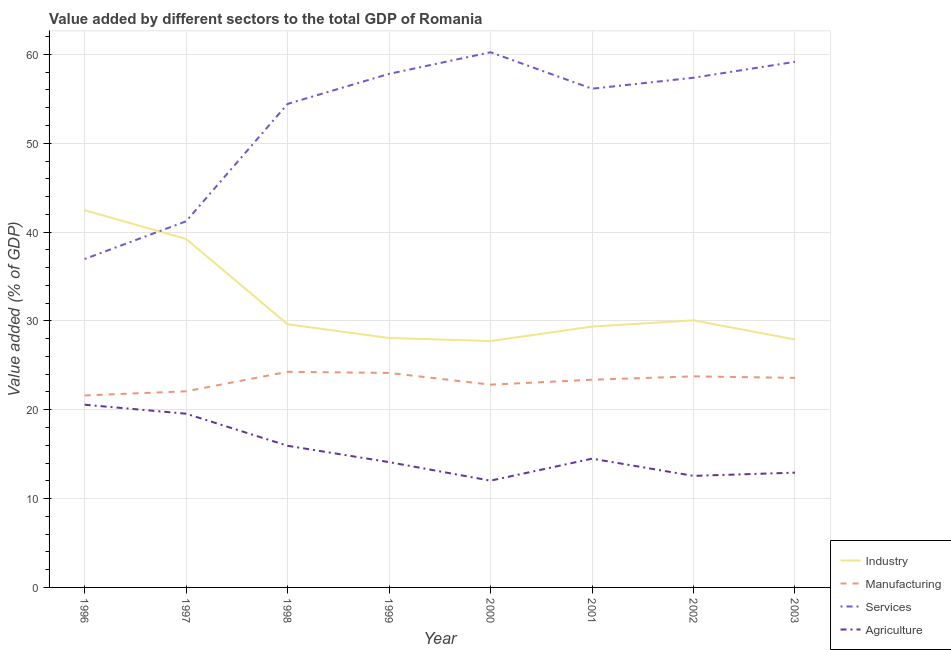Does the line corresponding to value added by services sector intersect with the line corresponding to value added by industrial sector?
Make the answer very short. Yes. Is the number of lines equal to the number of legend labels?
Keep it short and to the point. Yes. What is the value added by services sector in 2003?
Your response must be concise. 59.17. Across all years, what is the maximum value added by industrial sector?
Your response must be concise. 42.46. Across all years, what is the minimum value added by industrial sector?
Your response must be concise. 27.73. In which year was the value added by services sector minimum?
Your answer should be very brief. 1996. What is the total value added by industrial sector in the graph?
Your answer should be compact. 254.47. What is the difference between the value added by agricultural sector in 1999 and that in 2002?
Give a very brief answer. 1.55. What is the difference between the value added by industrial sector in 2000 and the value added by agricultural sector in 2001?
Provide a short and direct response. 13.24. What is the average value added by agricultural sector per year?
Your response must be concise. 15.27. In the year 2003, what is the difference between the value added by services sector and value added by industrial sector?
Your response must be concise. 31.26. In how many years, is the value added by industrial sector greater than 26 %?
Keep it short and to the point. 8. What is the ratio of the value added by services sector in 1998 to that in 2002?
Offer a very short reply. 0.95. What is the difference between the highest and the second highest value added by agricultural sector?
Provide a succinct answer. 1.01. What is the difference between the highest and the lowest value added by services sector?
Make the answer very short. 23.28. Does the value added by services sector monotonically increase over the years?
Keep it short and to the point. No. Is the value added by industrial sector strictly greater than the value added by manufacturing sector over the years?
Your answer should be compact. Yes. How many years are there in the graph?
Ensure brevity in your answer.  8. What is the difference between two consecutive major ticks on the Y-axis?
Give a very brief answer. 10. Does the graph contain any zero values?
Ensure brevity in your answer.  No. Does the graph contain grids?
Your answer should be compact. Yes. How many legend labels are there?
Offer a very short reply. 4. How are the legend labels stacked?
Your response must be concise. Vertical. What is the title of the graph?
Offer a very short reply. Value added by different sectors to the total GDP of Romania. Does "First 20% of population" appear as one of the legend labels in the graph?
Make the answer very short. No. What is the label or title of the Y-axis?
Provide a short and direct response. Value added (% of GDP). What is the Value added (% of GDP) of Industry in 1996?
Provide a short and direct response. 42.46. What is the Value added (% of GDP) in Manufacturing in 1996?
Your response must be concise. 21.61. What is the Value added (% of GDP) of Services in 1996?
Offer a very short reply. 36.97. What is the Value added (% of GDP) of Agriculture in 1996?
Give a very brief answer. 20.57. What is the Value added (% of GDP) in Industry in 1997?
Offer a very short reply. 39.23. What is the Value added (% of GDP) of Manufacturing in 1997?
Offer a terse response. 22.08. What is the Value added (% of GDP) of Services in 1997?
Your response must be concise. 41.22. What is the Value added (% of GDP) of Agriculture in 1997?
Ensure brevity in your answer.  19.56. What is the Value added (% of GDP) of Industry in 1998?
Offer a very short reply. 29.62. What is the Value added (% of GDP) of Manufacturing in 1998?
Give a very brief answer. 24.27. What is the Value added (% of GDP) in Services in 1998?
Make the answer very short. 54.43. What is the Value added (% of GDP) of Agriculture in 1998?
Give a very brief answer. 15.94. What is the Value added (% of GDP) in Industry in 1999?
Ensure brevity in your answer.  28.08. What is the Value added (% of GDP) of Manufacturing in 1999?
Give a very brief answer. 24.15. What is the Value added (% of GDP) in Services in 1999?
Provide a succinct answer. 57.81. What is the Value added (% of GDP) in Agriculture in 1999?
Make the answer very short. 14.11. What is the Value added (% of GDP) in Industry in 2000?
Your response must be concise. 27.73. What is the Value added (% of GDP) of Manufacturing in 2000?
Keep it short and to the point. 22.83. What is the Value added (% of GDP) in Services in 2000?
Ensure brevity in your answer.  60.25. What is the Value added (% of GDP) in Agriculture in 2000?
Offer a very short reply. 12.02. What is the Value added (% of GDP) in Industry in 2001?
Offer a terse response. 29.36. What is the Value added (% of GDP) of Manufacturing in 2001?
Your response must be concise. 23.38. What is the Value added (% of GDP) of Services in 2001?
Your response must be concise. 56.14. What is the Value added (% of GDP) of Agriculture in 2001?
Your answer should be very brief. 14.49. What is the Value added (% of GDP) in Industry in 2002?
Your answer should be compact. 30.07. What is the Value added (% of GDP) in Manufacturing in 2002?
Your answer should be compact. 23.76. What is the Value added (% of GDP) of Services in 2002?
Your answer should be very brief. 57.38. What is the Value added (% of GDP) in Agriculture in 2002?
Keep it short and to the point. 12.56. What is the Value added (% of GDP) in Industry in 2003?
Keep it short and to the point. 27.91. What is the Value added (% of GDP) in Manufacturing in 2003?
Give a very brief answer. 23.59. What is the Value added (% of GDP) of Services in 2003?
Provide a succinct answer. 59.17. What is the Value added (% of GDP) of Agriculture in 2003?
Your answer should be very brief. 12.92. Across all years, what is the maximum Value added (% of GDP) in Industry?
Provide a succinct answer. 42.46. Across all years, what is the maximum Value added (% of GDP) of Manufacturing?
Your answer should be very brief. 24.27. Across all years, what is the maximum Value added (% of GDP) of Services?
Ensure brevity in your answer.  60.25. Across all years, what is the maximum Value added (% of GDP) in Agriculture?
Keep it short and to the point. 20.57. Across all years, what is the minimum Value added (% of GDP) in Industry?
Your answer should be very brief. 27.73. Across all years, what is the minimum Value added (% of GDP) in Manufacturing?
Provide a succinct answer. 21.61. Across all years, what is the minimum Value added (% of GDP) of Services?
Provide a succinct answer. 36.97. Across all years, what is the minimum Value added (% of GDP) of Agriculture?
Offer a terse response. 12.02. What is the total Value added (% of GDP) in Industry in the graph?
Give a very brief answer. 254.47. What is the total Value added (% of GDP) in Manufacturing in the graph?
Provide a succinct answer. 185.66. What is the total Value added (% of GDP) in Services in the graph?
Provide a short and direct response. 423.36. What is the total Value added (% of GDP) in Agriculture in the graph?
Your answer should be compact. 122.17. What is the difference between the Value added (% of GDP) in Industry in 1996 and that in 1997?
Your answer should be very brief. 3.24. What is the difference between the Value added (% of GDP) in Manufacturing in 1996 and that in 1997?
Provide a succinct answer. -0.47. What is the difference between the Value added (% of GDP) of Services in 1996 and that in 1997?
Your response must be concise. -4.25. What is the difference between the Value added (% of GDP) in Agriculture in 1996 and that in 1997?
Offer a terse response. 1.01. What is the difference between the Value added (% of GDP) in Industry in 1996 and that in 1998?
Keep it short and to the point. 12.84. What is the difference between the Value added (% of GDP) of Manufacturing in 1996 and that in 1998?
Your answer should be very brief. -2.66. What is the difference between the Value added (% of GDP) of Services in 1996 and that in 1998?
Your answer should be compact. -17.46. What is the difference between the Value added (% of GDP) of Agriculture in 1996 and that in 1998?
Ensure brevity in your answer.  4.62. What is the difference between the Value added (% of GDP) of Industry in 1996 and that in 1999?
Offer a very short reply. 14.38. What is the difference between the Value added (% of GDP) in Manufacturing in 1996 and that in 1999?
Give a very brief answer. -2.53. What is the difference between the Value added (% of GDP) of Services in 1996 and that in 1999?
Make the answer very short. -20.84. What is the difference between the Value added (% of GDP) of Agriculture in 1996 and that in 1999?
Provide a short and direct response. 6.46. What is the difference between the Value added (% of GDP) in Industry in 1996 and that in 2000?
Ensure brevity in your answer.  14.73. What is the difference between the Value added (% of GDP) in Manufacturing in 1996 and that in 2000?
Your answer should be very brief. -1.21. What is the difference between the Value added (% of GDP) of Services in 1996 and that in 2000?
Offer a very short reply. -23.28. What is the difference between the Value added (% of GDP) in Agriculture in 1996 and that in 2000?
Your answer should be very brief. 8.55. What is the difference between the Value added (% of GDP) of Industry in 1996 and that in 2001?
Make the answer very short. 13.1. What is the difference between the Value added (% of GDP) of Manufacturing in 1996 and that in 2001?
Make the answer very short. -1.77. What is the difference between the Value added (% of GDP) in Services in 1996 and that in 2001?
Offer a terse response. -19.17. What is the difference between the Value added (% of GDP) in Agriculture in 1996 and that in 2001?
Ensure brevity in your answer.  6.07. What is the difference between the Value added (% of GDP) of Industry in 1996 and that in 2002?
Give a very brief answer. 12.4. What is the difference between the Value added (% of GDP) in Manufacturing in 1996 and that in 2002?
Give a very brief answer. -2.15. What is the difference between the Value added (% of GDP) in Services in 1996 and that in 2002?
Provide a succinct answer. -20.41. What is the difference between the Value added (% of GDP) in Agriculture in 1996 and that in 2002?
Your answer should be very brief. 8.01. What is the difference between the Value added (% of GDP) in Industry in 1996 and that in 2003?
Keep it short and to the point. 14.55. What is the difference between the Value added (% of GDP) of Manufacturing in 1996 and that in 2003?
Your answer should be very brief. -1.98. What is the difference between the Value added (% of GDP) of Services in 1996 and that in 2003?
Provide a short and direct response. -22.2. What is the difference between the Value added (% of GDP) in Agriculture in 1996 and that in 2003?
Your answer should be compact. 7.65. What is the difference between the Value added (% of GDP) of Industry in 1997 and that in 1998?
Provide a short and direct response. 9.6. What is the difference between the Value added (% of GDP) of Manufacturing in 1997 and that in 1998?
Provide a succinct answer. -2.19. What is the difference between the Value added (% of GDP) in Services in 1997 and that in 1998?
Keep it short and to the point. -13.21. What is the difference between the Value added (% of GDP) of Agriculture in 1997 and that in 1998?
Your response must be concise. 3.61. What is the difference between the Value added (% of GDP) of Industry in 1997 and that in 1999?
Your answer should be compact. 11.14. What is the difference between the Value added (% of GDP) of Manufacturing in 1997 and that in 1999?
Your response must be concise. -2.07. What is the difference between the Value added (% of GDP) in Services in 1997 and that in 1999?
Offer a very short reply. -16.59. What is the difference between the Value added (% of GDP) of Agriculture in 1997 and that in 1999?
Your answer should be compact. 5.45. What is the difference between the Value added (% of GDP) of Industry in 1997 and that in 2000?
Give a very brief answer. 11.49. What is the difference between the Value added (% of GDP) in Manufacturing in 1997 and that in 2000?
Your answer should be very brief. -0.75. What is the difference between the Value added (% of GDP) of Services in 1997 and that in 2000?
Make the answer very short. -19.03. What is the difference between the Value added (% of GDP) in Agriculture in 1997 and that in 2000?
Make the answer very short. 7.54. What is the difference between the Value added (% of GDP) in Industry in 1997 and that in 2001?
Your response must be concise. 9.86. What is the difference between the Value added (% of GDP) of Manufacturing in 1997 and that in 2001?
Offer a very short reply. -1.3. What is the difference between the Value added (% of GDP) of Services in 1997 and that in 2001?
Make the answer very short. -14.92. What is the difference between the Value added (% of GDP) of Agriculture in 1997 and that in 2001?
Provide a succinct answer. 5.06. What is the difference between the Value added (% of GDP) in Industry in 1997 and that in 2002?
Provide a succinct answer. 9.16. What is the difference between the Value added (% of GDP) of Manufacturing in 1997 and that in 2002?
Provide a short and direct response. -1.68. What is the difference between the Value added (% of GDP) of Services in 1997 and that in 2002?
Make the answer very short. -16.16. What is the difference between the Value added (% of GDP) of Agriculture in 1997 and that in 2002?
Offer a very short reply. 7. What is the difference between the Value added (% of GDP) of Industry in 1997 and that in 2003?
Offer a very short reply. 11.32. What is the difference between the Value added (% of GDP) of Manufacturing in 1997 and that in 2003?
Your response must be concise. -1.51. What is the difference between the Value added (% of GDP) of Services in 1997 and that in 2003?
Give a very brief answer. -17.95. What is the difference between the Value added (% of GDP) of Agriculture in 1997 and that in 2003?
Ensure brevity in your answer.  6.64. What is the difference between the Value added (% of GDP) of Industry in 1998 and that in 1999?
Provide a short and direct response. 1.54. What is the difference between the Value added (% of GDP) in Manufacturing in 1998 and that in 1999?
Offer a terse response. 0.13. What is the difference between the Value added (% of GDP) in Services in 1998 and that in 1999?
Provide a short and direct response. -3.38. What is the difference between the Value added (% of GDP) in Agriculture in 1998 and that in 1999?
Your answer should be very brief. 1.84. What is the difference between the Value added (% of GDP) of Industry in 1998 and that in 2000?
Give a very brief answer. 1.89. What is the difference between the Value added (% of GDP) of Manufacturing in 1998 and that in 2000?
Your response must be concise. 1.45. What is the difference between the Value added (% of GDP) in Services in 1998 and that in 2000?
Your answer should be compact. -5.81. What is the difference between the Value added (% of GDP) in Agriculture in 1998 and that in 2000?
Ensure brevity in your answer.  3.92. What is the difference between the Value added (% of GDP) in Industry in 1998 and that in 2001?
Give a very brief answer. 0.26. What is the difference between the Value added (% of GDP) in Manufacturing in 1998 and that in 2001?
Give a very brief answer. 0.89. What is the difference between the Value added (% of GDP) in Services in 1998 and that in 2001?
Your answer should be very brief. -1.71. What is the difference between the Value added (% of GDP) of Agriculture in 1998 and that in 2001?
Keep it short and to the point. 1.45. What is the difference between the Value added (% of GDP) in Industry in 1998 and that in 2002?
Make the answer very short. -0.44. What is the difference between the Value added (% of GDP) in Manufacturing in 1998 and that in 2002?
Ensure brevity in your answer.  0.51. What is the difference between the Value added (% of GDP) of Services in 1998 and that in 2002?
Offer a terse response. -2.94. What is the difference between the Value added (% of GDP) of Agriculture in 1998 and that in 2002?
Provide a succinct answer. 3.39. What is the difference between the Value added (% of GDP) in Industry in 1998 and that in 2003?
Offer a terse response. 1.71. What is the difference between the Value added (% of GDP) in Manufacturing in 1998 and that in 2003?
Keep it short and to the point. 0.68. What is the difference between the Value added (% of GDP) in Services in 1998 and that in 2003?
Your answer should be compact. -4.74. What is the difference between the Value added (% of GDP) of Agriculture in 1998 and that in 2003?
Your answer should be compact. 3.02. What is the difference between the Value added (% of GDP) of Industry in 1999 and that in 2000?
Make the answer very short. 0.35. What is the difference between the Value added (% of GDP) in Manufacturing in 1999 and that in 2000?
Your answer should be very brief. 1.32. What is the difference between the Value added (% of GDP) in Services in 1999 and that in 2000?
Make the answer very short. -2.43. What is the difference between the Value added (% of GDP) of Agriculture in 1999 and that in 2000?
Ensure brevity in your answer.  2.09. What is the difference between the Value added (% of GDP) in Industry in 1999 and that in 2001?
Your answer should be compact. -1.28. What is the difference between the Value added (% of GDP) in Manufacturing in 1999 and that in 2001?
Keep it short and to the point. 0.77. What is the difference between the Value added (% of GDP) in Services in 1999 and that in 2001?
Make the answer very short. 1.67. What is the difference between the Value added (% of GDP) in Agriculture in 1999 and that in 2001?
Your answer should be very brief. -0.39. What is the difference between the Value added (% of GDP) in Industry in 1999 and that in 2002?
Offer a very short reply. -1.98. What is the difference between the Value added (% of GDP) in Manufacturing in 1999 and that in 2002?
Provide a short and direct response. 0.38. What is the difference between the Value added (% of GDP) of Services in 1999 and that in 2002?
Keep it short and to the point. 0.44. What is the difference between the Value added (% of GDP) of Agriculture in 1999 and that in 2002?
Your answer should be compact. 1.55. What is the difference between the Value added (% of GDP) of Industry in 1999 and that in 2003?
Your answer should be compact. 0.17. What is the difference between the Value added (% of GDP) in Manufacturing in 1999 and that in 2003?
Your answer should be very brief. 0.56. What is the difference between the Value added (% of GDP) in Services in 1999 and that in 2003?
Ensure brevity in your answer.  -1.36. What is the difference between the Value added (% of GDP) in Agriculture in 1999 and that in 2003?
Give a very brief answer. 1.19. What is the difference between the Value added (% of GDP) in Industry in 2000 and that in 2001?
Your answer should be very brief. -1.63. What is the difference between the Value added (% of GDP) in Manufacturing in 2000 and that in 2001?
Your answer should be compact. -0.56. What is the difference between the Value added (% of GDP) of Services in 2000 and that in 2001?
Your answer should be very brief. 4.1. What is the difference between the Value added (% of GDP) in Agriculture in 2000 and that in 2001?
Your answer should be very brief. -2.47. What is the difference between the Value added (% of GDP) in Industry in 2000 and that in 2002?
Offer a terse response. -2.33. What is the difference between the Value added (% of GDP) of Manufacturing in 2000 and that in 2002?
Your answer should be very brief. -0.94. What is the difference between the Value added (% of GDP) of Services in 2000 and that in 2002?
Offer a terse response. 2.87. What is the difference between the Value added (% of GDP) of Agriculture in 2000 and that in 2002?
Your answer should be very brief. -0.54. What is the difference between the Value added (% of GDP) of Industry in 2000 and that in 2003?
Provide a succinct answer. -0.18. What is the difference between the Value added (% of GDP) of Manufacturing in 2000 and that in 2003?
Provide a succinct answer. -0.76. What is the difference between the Value added (% of GDP) of Services in 2000 and that in 2003?
Give a very brief answer. 1.08. What is the difference between the Value added (% of GDP) of Agriculture in 2000 and that in 2003?
Your answer should be compact. -0.9. What is the difference between the Value added (% of GDP) of Industry in 2001 and that in 2002?
Keep it short and to the point. -0.7. What is the difference between the Value added (% of GDP) in Manufacturing in 2001 and that in 2002?
Your answer should be very brief. -0.38. What is the difference between the Value added (% of GDP) of Services in 2001 and that in 2002?
Give a very brief answer. -1.24. What is the difference between the Value added (% of GDP) in Agriculture in 2001 and that in 2002?
Your answer should be very brief. 1.94. What is the difference between the Value added (% of GDP) in Industry in 2001 and that in 2003?
Provide a short and direct response. 1.45. What is the difference between the Value added (% of GDP) in Manufacturing in 2001 and that in 2003?
Ensure brevity in your answer.  -0.21. What is the difference between the Value added (% of GDP) in Services in 2001 and that in 2003?
Ensure brevity in your answer.  -3.03. What is the difference between the Value added (% of GDP) in Agriculture in 2001 and that in 2003?
Your answer should be very brief. 1.57. What is the difference between the Value added (% of GDP) in Industry in 2002 and that in 2003?
Offer a very short reply. 2.16. What is the difference between the Value added (% of GDP) of Manufacturing in 2002 and that in 2003?
Ensure brevity in your answer.  0.17. What is the difference between the Value added (% of GDP) of Services in 2002 and that in 2003?
Offer a very short reply. -1.79. What is the difference between the Value added (% of GDP) of Agriculture in 2002 and that in 2003?
Offer a very short reply. -0.36. What is the difference between the Value added (% of GDP) of Industry in 1996 and the Value added (% of GDP) of Manufacturing in 1997?
Offer a very short reply. 20.38. What is the difference between the Value added (% of GDP) in Industry in 1996 and the Value added (% of GDP) in Services in 1997?
Make the answer very short. 1.24. What is the difference between the Value added (% of GDP) of Industry in 1996 and the Value added (% of GDP) of Agriculture in 1997?
Make the answer very short. 22.9. What is the difference between the Value added (% of GDP) in Manufacturing in 1996 and the Value added (% of GDP) in Services in 1997?
Offer a terse response. -19.6. What is the difference between the Value added (% of GDP) in Manufacturing in 1996 and the Value added (% of GDP) in Agriculture in 1997?
Offer a terse response. 2.06. What is the difference between the Value added (% of GDP) in Services in 1996 and the Value added (% of GDP) in Agriculture in 1997?
Offer a very short reply. 17.41. What is the difference between the Value added (% of GDP) of Industry in 1996 and the Value added (% of GDP) of Manufacturing in 1998?
Offer a very short reply. 18.19. What is the difference between the Value added (% of GDP) of Industry in 1996 and the Value added (% of GDP) of Services in 1998?
Your answer should be compact. -11.97. What is the difference between the Value added (% of GDP) in Industry in 1996 and the Value added (% of GDP) in Agriculture in 1998?
Keep it short and to the point. 26.52. What is the difference between the Value added (% of GDP) in Manufacturing in 1996 and the Value added (% of GDP) in Services in 1998?
Your answer should be very brief. -32.82. What is the difference between the Value added (% of GDP) in Manufacturing in 1996 and the Value added (% of GDP) in Agriculture in 1998?
Ensure brevity in your answer.  5.67. What is the difference between the Value added (% of GDP) in Services in 1996 and the Value added (% of GDP) in Agriculture in 1998?
Offer a terse response. 21.03. What is the difference between the Value added (% of GDP) in Industry in 1996 and the Value added (% of GDP) in Manufacturing in 1999?
Offer a terse response. 18.32. What is the difference between the Value added (% of GDP) in Industry in 1996 and the Value added (% of GDP) in Services in 1999?
Your answer should be very brief. -15.35. What is the difference between the Value added (% of GDP) in Industry in 1996 and the Value added (% of GDP) in Agriculture in 1999?
Offer a terse response. 28.36. What is the difference between the Value added (% of GDP) in Manufacturing in 1996 and the Value added (% of GDP) in Services in 1999?
Your answer should be very brief. -36.2. What is the difference between the Value added (% of GDP) in Manufacturing in 1996 and the Value added (% of GDP) in Agriculture in 1999?
Give a very brief answer. 7.51. What is the difference between the Value added (% of GDP) in Services in 1996 and the Value added (% of GDP) in Agriculture in 1999?
Ensure brevity in your answer.  22.86. What is the difference between the Value added (% of GDP) in Industry in 1996 and the Value added (% of GDP) in Manufacturing in 2000?
Provide a succinct answer. 19.64. What is the difference between the Value added (% of GDP) in Industry in 1996 and the Value added (% of GDP) in Services in 2000?
Offer a very short reply. -17.78. What is the difference between the Value added (% of GDP) in Industry in 1996 and the Value added (% of GDP) in Agriculture in 2000?
Keep it short and to the point. 30.44. What is the difference between the Value added (% of GDP) of Manufacturing in 1996 and the Value added (% of GDP) of Services in 2000?
Make the answer very short. -38.63. What is the difference between the Value added (% of GDP) of Manufacturing in 1996 and the Value added (% of GDP) of Agriculture in 2000?
Give a very brief answer. 9.59. What is the difference between the Value added (% of GDP) in Services in 1996 and the Value added (% of GDP) in Agriculture in 2000?
Keep it short and to the point. 24.95. What is the difference between the Value added (% of GDP) of Industry in 1996 and the Value added (% of GDP) of Manufacturing in 2001?
Your response must be concise. 19.08. What is the difference between the Value added (% of GDP) of Industry in 1996 and the Value added (% of GDP) of Services in 2001?
Provide a succinct answer. -13.68. What is the difference between the Value added (% of GDP) in Industry in 1996 and the Value added (% of GDP) in Agriculture in 2001?
Make the answer very short. 27.97. What is the difference between the Value added (% of GDP) of Manufacturing in 1996 and the Value added (% of GDP) of Services in 2001?
Your response must be concise. -34.53. What is the difference between the Value added (% of GDP) in Manufacturing in 1996 and the Value added (% of GDP) in Agriculture in 2001?
Make the answer very short. 7.12. What is the difference between the Value added (% of GDP) of Services in 1996 and the Value added (% of GDP) of Agriculture in 2001?
Give a very brief answer. 22.48. What is the difference between the Value added (% of GDP) of Industry in 1996 and the Value added (% of GDP) of Manufacturing in 2002?
Make the answer very short. 18.7. What is the difference between the Value added (% of GDP) in Industry in 1996 and the Value added (% of GDP) in Services in 2002?
Keep it short and to the point. -14.91. What is the difference between the Value added (% of GDP) in Industry in 1996 and the Value added (% of GDP) in Agriculture in 2002?
Ensure brevity in your answer.  29.9. What is the difference between the Value added (% of GDP) of Manufacturing in 1996 and the Value added (% of GDP) of Services in 2002?
Make the answer very short. -35.76. What is the difference between the Value added (% of GDP) of Manufacturing in 1996 and the Value added (% of GDP) of Agriculture in 2002?
Provide a succinct answer. 9.05. What is the difference between the Value added (% of GDP) in Services in 1996 and the Value added (% of GDP) in Agriculture in 2002?
Offer a terse response. 24.41. What is the difference between the Value added (% of GDP) of Industry in 1996 and the Value added (% of GDP) of Manufacturing in 2003?
Keep it short and to the point. 18.87. What is the difference between the Value added (% of GDP) of Industry in 1996 and the Value added (% of GDP) of Services in 2003?
Give a very brief answer. -16.71. What is the difference between the Value added (% of GDP) of Industry in 1996 and the Value added (% of GDP) of Agriculture in 2003?
Your answer should be very brief. 29.54. What is the difference between the Value added (% of GDP) in Manufacturing in 1996 and the Value added (% of GDP) in Services in 2003?
Your answer should be very brief. -37.56. What is the difference between the Value added (% of GDP) of Manufacturing in 1996 and the Value added (% of GDP) of Agriculture in 2003?
Your answer should be very brief. 8.69. What is the difference between the Value added (% of GDP) of Services in 1996 and the Value added (% of GDP) of Agriculture in 2003?
Provide a succinct answer. 24.05. What is the difference between the Value added (% of GDP) in Industry in 1997 and the Value added (% of GDP) in Manufacturing in 1998?
Make the answer very short. 14.95. What is the difference between the Value added (% of GDP) in Industry in 1997 and the Value added (% of GDP) in Services in 1998?
Offer a terse response. -15.21. What is the difference between the Value added (% of GDP) in Industry in 1997 and the Value added (% of GDP) in Agriculture in 1998?
Your response must be concise. 23.28. What is the difference between the Value added (% of GDP) of Manufacturing in 1997 and the Value added (% of GDP) of Services in 1998?
Your response must be concise. -32.35. What is the difference between the Value added (% of GDP) in Manufacturing in 1997 and the Value added (% of GDP) in Agriculture in 1998?
Provide a short and direct response. 6.13. What is the difference between the Value added (% of GDP) in Services in 1997 and the Value added (% of GDP) in Agriculture in 1998?
Your answer should be compact. 25.27. What is the difference between the Value added (% of GDP) of Industry in 1997 and the Value added (% of GDP) of Manufacturing in 1999?
Make the answer very short. 15.08. What is the difference between the Value added (% of GDP) in Industry in 1997 and the Value added (% of GDP) in Services in 1999?
Provide a short and direct response. -18.59. What is the difference between the Value added (% of GDP) in Industry in 1997 and the Value added (% of GDP) in Agriculture in 1999?
Provide a short and direct response. 25.12. What is the difference between the Value added (% of GDP) of Manufacturing in 1997 and the Value added (% of GDP) of Services in 1999?
Your response must be concise. -35.73. What is the difference between the Value added (% of GDP) of Manufacturing in 1997 and the Value added (% of GDP) of Agriculture in 1999?
Ensure brevity in your answer.  7.97. What is the difference between the Value added (% of GDP) in Services in 1997 and the Value added (% of GDP) in Agriculture in 1999?
Your answer should be very brief. 27.11. What is the difference between the Value added (% of GDP) in Industry in 1997 and the Value added (% of GDP) in Manufacturing in 2000?
Provide a succinct answer. 16.4. What is the difference between the Value added (% of GDP) in Industry in 1997 and the Value added (% of GDP) in Services in 2000?
Provide a succinct answer. -21.02. What is the difference between the Value added (% of GDP) in Industry in 1997 and the Value added (% of GDP) in Agriculture in 2000?
Your answer should be very brief. 27.21. What is the difference between the Value added (% of GDP) of Manufacturing in 1997 and the Value added (% of GDP) of Services in 2000?
Make the answer very short. -38.17. What is the difference between the Value added (% of GDP) of Manufacturing in 1997 and the Value added (% of GDP) of Agriculture in 2000?
Provide a short and direct response. 10.06. What is the difference between the Value added (% of GDP) of Services in 1997 and the Value added (% of GDP) of Agriculture in 2000?
Provide a short and direct response. 29.2. What is the difference between the Value added (% of GDP) of Industry in 1997 and the Value added (% of GDP) of Manufacturing in 2001?
Ensure brevity in your answer.  15.85. What is the difference between the Value added (% of GDP) of Industry in 1997 and the Value added (% of GDP) of Services in 2001?
Make the answer very short. -16.92. What is the difference between the Value added (% of GDP) of Industry in 1997 and the Value added (% of GDP) of Agriculture in 2001?
Your answer should be very brief. 24.73. What is the difference between the Value added (% of GDP) in Manufacturing in 1997 and the Value added (% of GDP) in Services in 2001?
Provide a succinct answer. -34.06. What is the difference between the Value added (% of GDP) in Manufacturing in 1997 and the Value added (% of GDP) in Agriculture in 2001?
Give a very brief answer. 7.58. What is the difference between the Value added (% of GDP) in Services in 1997 and the Value added (% of GDP) in Agriculture in 2001?
Your response must be concise. 26.72. What is the difference between the Value added (% of GDP) of Industry in 1997 and the Value added (% of GDP) of Manufacturing in 2002?
Give a very brief answer. 15.46. What is the difference between the Value added (% of GDP) in Industry in 1997 and the Value added (% of GDP) in Services in 2002?
Your response must be concise. -18.15. What is the difference between the Value added (% of GDP) in Industry in 1997 and the Value added (% of GDP) in Agriculture in 2002?
Ensure brevity in your answer.  26.67. What is the difference between the Value added (% of GDP) of Manufacturing in 1997 and the Value added (% of GDP) of Services in 2002?
Your response must be concise. -35.3. What is the difference between the Value added (% of GDP) in Manufacturing in 1997 and the Value added (% of GDP) in Agriculture in 2002?
Your answer should be compact. 9.52. What is the difference between the Value added (% of GDP) of Services in 1997 and the Value added (% of GDP) of Agriculture in 2002?
Your answer should be very brief. 28.66. What is the difference between the Value added (% of GDP) of Industry in 1997 and the Value added (% of GDP) of Manufacturing in 2003?
Offer a terse response. 15.64. What is the difference between the Value added (% of GDP) in Industry in 1997 and the Value added (% of GDP) in Services in 2003?
Ensure brevity in your answer.  -19.94. What is the difference between the Value added (% of GDP) in Industry in 1997 and the Value added (% of GDP) in Agriculture in 2003?
Provide a succinct answer. 26.3. What is the difference between the Value added (% of GDP) in Manufacturing in 1997 and the Value added (% of GDP) in Services in 2003?
Keep it short and to the point. -37.09. What is the difference between the Value added (% of GDP) in Manufacturing in 1997 and the Value added (% of GDP) in Agriculture in 2003?
Your response must be concise. 9.16. What is the difference between the Value added (% of GDP) in Services in 1997 and the Value added (% of GDP) in Agriculture in 2003?
Your answer should be very brief. 28.3. What is the difference between the Value added (% of GDP) in Industry in 1998 and the Value added (% of GDP) in Manufacturing in 1999?
Offer a very short reply. 5.48. What is the difference between the Value added (% of GDP) of Industry in 1998 and the Value added (% of GDP) of Services in 1999?
Ensure brevity in your answer.  -28.19. What is the difference between the Value added (% of GDP) of Industry in 1998 and the Value added (% of GDP) of Agriculture in 1999?
Keep it short and to the point. 15.52. What is the difference between the Value added (% of GDP) of Manufacturing in 1998 and the Value added (% of GDP) of Services in 1999?
Your response must be concise. -33.54. What is the difference between the Value added (% of GDP) in Manufacturing in 1998 and the Value added (% of GDP) in Agriculture in 1999?
Your response must be concise. 10.17. What is the difference between the Value added (% of GDP) of Services in 1998 and the Value added (% of GDP) of Agriculture in 1999?
Your answer should be very brief. 40.33. What is the difference between the Value added (% of GDP) in Industry in 1998 and the Value added (% of GDP) in Manufacturing in 2000?
Provide a short and direct response. 6.8. What is the difference between the Value added (% of GDP) in Industry in 1998 and the Value added (% of GDP) in Services in 2000?
Your answer should be very brief. -30.62. What is the difference between the Value added (% of GDP) of Industry in 1998 and the Value added (% of GDP) of Agriculture in 2000?
Your answer should be very brief. 17.6. What is the difference between the Value added (% of GDP) of Manufacturing in 1998 and the Value added (% of GDP) of Services in 2000?
Your response must be concise. -35.97. What is the difference between the Value added (% of GDP) of Manufacturing in 1998 and the Value added (% of GDP) of Agriculture in 2000?
Give a very brief answer. 12.25. What is the difference between the Value added (% of GDP) in Services in 1998 and the Value added (% of GDP) in Agriculture in 2000?
Provide a short and direct response. 42.41. What is the difference between the Value added (% of GDP) of Industry in 1998 and the Value added (% of GDP) of Manufacturing in 2001?
Provide a short and direct response. 6.24. What is the difference between the Value added (% of GDP) of Industry in 1998 and the Value added (% of GDP) of Services in 2001?
Offer a very short reply. -26.52. What is the difference between the Value added (% of GDP) in Industry in 1998 and the Value added (% of GDP) in Agriculture in 2001?
Provide a short and direct response. 15.13. What is the difference between the Value added (% of GDP) in Manufacturing in 1998 and the Value added (% of GDP) in Services in 2001?
Ensure brevity in your answer.  -31.87. What is the difference between the Value added (% of GDP) in Manufacturing in 1998 and the Value added (% of GDP) in Agriculture in 2001?
Provide a short and direct response. 9.78. What is the difference between the Value added (% of GDP) in Services in 1998 and the Value added (% of GDP) in Agriculture in 2001?
Give a very brief answer. 39.94. What is the difference between the Value added (% of GDP) in Industry in 1998 and the Value added (% of GDP) in Manufacturing in 2002?
Provide a succinct answer. 5.86. What is the difference between the Value added (% of GDP) of Industry in 1998 and the Value added (% of GDP) of Services in 2002?
Your response must be concise. -27.75. What is the difference between the Value added (% of GDP) of Industry in 1998 and the Value added (% of GDP) of Agriculture in 2002?
Provide a short and direct response. 17.07. What is the difference between the Value added (% of GDP) in Manufacturing in 1998 and the Value added (% of GDP) in Services in 2002?
Your answer should be compact. -33.1. What is the difference between the Value added (% of GDP) in Manufacturing in 1998 and the Value added (% of GDP) in Agriculture in 2002?
Provide a short and direct response. 11.71. What is the difference between the Value added (% of GDP) of Services in 1998 and the Value added (% of GDP) of Agriculture in 2002?
Give a very brief answer. 41.87. What is the difference between the Value added (% of GDP) in Industry in 1998 and the Value added (% of GDP) in Manufacturing in 2003?
Offer a very short reply. 6.04. What is the difference between the Value added (% of GDP) of Industry in 1998 and the Value added (% of GDP) of Services in 2003?
Your answer should be very brief. -29.55. What is the difference between the Value added (% of GDP) in Industry in 1998 and the Value added (% of GDP) in Agriculture in 2003?
Provide a succinct answer. 16.7. What is the difference between the Value added (% of GDP) of Manufacturing in 1998 and the Value added (% of GDP) of Services in 2003?
Your response must be concise. -34.9. What is the difference between the Value added (% of GDP) of Manufacturing in 1998 and the Value added (% of GDP) of Agriculture in 2003?
Make the answer very short. 11.35. What is the difference between the Value added (% of GDP) of Services in 1998 and the Value added (% of GDP) of Agriculture in 2003?
Your answer should be very brief. 41.51. What is the difference between the Value added (% of GDP) of Industry in 1999 and the Value added (% of GDP) of Manufacturing in 2000?
Provide a short and direct response. 5.26. What is the difference between the Value added (% of GDP) in Industry in 1999 and the Value added (% of GDP) in Services in 2000?
Give a very brief answer. -32.16. What is the difference between the Value added (% of GDP) of Industry in 1999 and the Value added (% of GDP) of Agriculture in 2000?
Make the answer very short. 16.06. What is the difference between the Value added (% of GDP) of Manufacturing in 1999 and the Value added (% of GDP) of Services in 2000?
Give a very brief answer. -36.1. What is the difference between the Value added (% of GDP) of Manufacturing in 1999 and the Value added (% of GDP) of Agriculture in 2000?
Offer a terse response. 12.13. What is the difference between the Value added (% of GDP) in Services in 1999 and the Value added (% of GDP) in Agriculture in 2000?
Offer a very short reply. 45.79. What is the difference between the Value added (% of GDP) in Industry in 1999 and the Value added (% of GDP) in Manufacturing in 2001?
Make the answer very short. 4.7. What is the difference between the Value added (% of GDP) in Industry in 1999 and the Value added (% of GDP) in Services in 2001?
Keep it short and to the point. -28.06. What is the difference between the Value added (% of GDP) in Industry in 1999 and the Value added (% of GDP) in Agriculture in 2001?
Your answer should be very brief. 13.59. What is the difference between the Value added (% of GDP) of Manufacturing in 1999 and the Value added (% of GDP) of Services in 2001?
Offer a terse response. -32. What is the difference between the Value added (% of GDP) of Manufacturing in 1999 and the Value added (% of GDP) of Agriculture in 2001?
Provide a succinct answer. 9.65. What is the difference between the Value added (% of GDP) of Services in 1999 and the Value added (% of GDP) of Agriculture in 2001?
Your answer should be very brief. 43.32. What is the difference between the Value added (% of GDP) in Industry in 1999 and the Value added (% of GDP) in Manufacturing in 2002?
Offer a very short reply. 4.32. What is the difference between the Value added (% of GDP) in Industry in 1999 and the Value added (% of GDP) in Services in 2002?
Your response must be concise. -29.29. What is the difference between the Value added (% of GDP) in Industry in 1999 and the Value added (% of GDP) in Agriculture in 2002?
Your answer should be very brief. 15.52. What is the difference between the Value added (% of GDP) of Manufacturing in 1999 and the Value added (% of GDP) of Services in 2002?
Provide a short and direct response. -33.23. What is the difference between the Value added (% of GDP) of Manufacturing in 1999 and the Value added (% of GDP) of Agriculture in 2002?
Keep it short and to the point. 11.59. What is the difference between the Value added (% of GDP) in Services in 1999 and the Value added (% of GDP) in Agriculture in 2002?
Ensure brevity in your answer.  45.25. What is the difference between the Value added (% of GDP) of Industry in 1999 and the Value added (% of GDP) of Manufacturing in 2003?
Ensure brevity in your answer.  4.49. What is the difference between the Value added (% of GDP) in Industry in 1999 and the Value added (% of GDP) in Services in 2003?
Provide a succinct answer. -31.09. What is the difference between the Value added (% of GDP) of Industry in 1999 and the Value added (% of GDP) of Agriculture in 2003?
Your answer should be compact. 15.16. What is the difference between the Value added (% of GDP) in Manufacturing in 1999 and the Value added (% of GDP) in Services in 2003?
Make the answer very short. -35.02. What is the difference between the Value added (% of GDP) of Manufacturing in 1999 and the Value added (% of GDP) of Agriculture in 2003?
Your answer should be very brief. 11.23. What is the difference between the Value added (% of GDP) in Services in 1999 and the Value added (% of GDP) in Agriculture in 2003?
Your answer should be compact. 44.89. What is the difference between the Value added (% of GDP) in Industry in 2000 and the Value added (% of GDP) in Manufacturing in 2001?
Keep it short and to the point. 4.35. What is the difference between the Value added (% of GDP) in Industry in 2000 and the Value added (% of GDP) in Services in 2001?
Provide a short and direct response. -28.41. What is the difference between the Value added (% of GDP) of Industry in 2000 and the Value added (% of GDP) of Agriculture in 2001?
Provide a short and direct response. 13.24. What is the difference between the Value added (% of GDP) of Manufacturing in 2000 and the Value added (% of GDP) of Services in 2001?
Give a very brief answer. -33.32. What is the difference between the Value added (% of GDP) of Manufacturing in 2000 and the Value added (% of GDP) of Agriculture in 2001?
Offer a very short reply. 8.33. What is the difference between the Value added (% of GDP) of Services in 2000 and the Value added (% of GDP) of Agriculture in 2001?
Make the answer very short. 45.75. What is the difference between the Value added (% of GDP) of Industry in 2000 and the Value added (% of GDP) of Manufacturing in 2002?
Your answer should be very brief. 3.97. What is the difference between the Value added (% of GDP) of Industry in 2000 and the Value added (% of GDP) of Services in 2002?
Make the answer very short. -29.64. What is the difference between the Value added (% of GDP) of Industry in 2000 and the Value added (% of GDP) of Agriculture in 2002?
Offer a terse response. 15.18. What is the difference between the Value added (% of GDP) of Manufacturing in 2000 and the Value added (% of GDP) of Services in 2002?
Make the answer very short. -34.55. What is the difference between the Value added (% of GDP) in Manufacturing in 2000 and the Value added (% of GDP) in Agriculture in 2002?
Keep it short and to the point. 10.27. What is the difference between the Value added (% of GDP) in Services in 2000 and the Value added (% of GDP) in Agriculture in 2002?
Your answer should be compact. 47.69. What is the difference between the Value added (% of GDP) in Industry in 2000 and the Value added (% of GDP) in Manufacturing in 2003?
Your response must be concise. 4.15. What is the difference between the Value added (% of GDP) in Industry in 2000 and the Value added (% of GDP) in Services in 2003?
Keep it short and to the point. -31.43. What is the difference between the Value added (% of GDP) in Industry in 2000 and the Value added (% of GDP) in Agriculture in 2003?
Give a very brief answer. 14.81. What is the difference between the Value added (% of GDP) of Manufacturing in 2000 and the Value added (% of GDP) of Services in 2003?
Your answer should be very brief. -36.34. What is the difference between the Value added (% of GDP) of Manufacturing in 2000 and the Value added (% of GDP) of Agriculture in 2003?
Ensure brevity in your answer.  9.9. What is the difference between the Value added (% of GDP) of Services in 2000 and the Value added (% of GDP) of Agriculture in 2003?
Provide a succinct answer. 47.33. What is the difference between the Value added (% of GDP) in Industry in 2001 and the Value added (% of GDP) in Manufacturing in 2002?
Ensure brevity in your answer.  5.6. What is the difference between the Value added (% of GDP) in Industry in 2001 and the Value added (% of GDP) in Services in 2002?
Keep it short and to the point. -28.01. What is the difference between the Value added (% of GDP) in Industry in 2001 and the Value added (% of GDP) in Agriculture in 2002?
Offer a very short reply. 16.81. What is the difference between the Value added (% of GDP) of Manufacturing in 2001 and the Value added (% of GDP) of Services in 2002?
Your answer should be very brief. -34. What is the difference between the Value added (% of GDP) of Manufacturing in 2001 and the Value added (% of GDP) of Agriculture in 2002?
Your response must be concise. 10.82. What is the difference between the Value added (% of GDP) in Services in 2001 and the Value added (% of GDP) in Agriculture in 2002?
Give a very brief answer. 43.58. What is the difference between the Value added (% of GDP) of Industry in 2001 and the Value added (% of GDP) of Manufacturing in 2003?
Your answer should be very brief. 5.78. What is the difference between the Value added (% of GDP) of Industry in 2001 and the Value added (% of GDP) of Services in 2003?
Offer a terse response. -29.8. What is the difference between the Value added (% of GDP) in Industry in 2001 and the Value added (% of GDP) in Agriculture in 2003?
Give a very brief answer. 16.44. What is the difference between the Value added (% of GDP) in Manufacturing in 2001 and the Value added (% of GDP) in Services in 2003?
Your response must be concise. -35.79. What is the difference between the Value added (% of GDP) in Manufacturing in 2001 and the Value added (% of GDP) in Agriculture in 2003?
Offer a very short reply. 10.46. What is the difference between the Value added (% of GDP) of Services in 2001 and the Value added (% of GDP) of Agriculture in 2003?
Offer a very short reply. 43.22. What is the difference between the Value added (% of GDP) in Industry in 2002 and the Value added (% of GDP) in Manufacturing in 2003?
Your answer should be compact. 6.48. What is the difference between the Value added (% of GDP) in Industry in 2002 and the Value added (% of GDP) in Services in 2003?
Ensure brevity in your answer.  -29.1. What is the difference between the Value added (% of GDP) of Industry in 2002 and the Value added (% of GDP) of Agriculture in 2003?
Ensure brevity in your answer.  17.15. What is the difference between the Value added (% of GDP) of Manufacturing in 2002 and the Value added (% of GDP) of Services in 2003?
Give a very brief answer. -35.41. What is the difference between the Value added (% of GDP) in Manufacturing in 2002 and the Value added (% of GDP) in Agriculture in 2003?
Offer a very short reply. 10.84. What is the difference between the Value added (% of GDP) of Services in 2002 and the Value added (% of GDP) of Agriculture in 2003?
Ensure brevity in your answer.  44.46. What is the average Value added (% of GDP) in Industry per year?
Ensure brevity in your answer.  31.81. What is the average Value added (% of GDP) in Manufacturing per year?
Give a very brief answer. 23.21. What is the average Value added (% of GDP) of Services per year?
Your answer should be very brief. 52.92. What is the average Value added (% of GDP) of Agriculture per year?
Keep it short and to the point. 15.27. In the year 1996, what is the difference between the Value added (% of GDP) of Industry and Value added (% of GDP) of Manufacturing?
Your answer should be very brief. 20.85. In the year 1996, what is the difference between the Value added (% of GDP) of Industry and Value added (% of GDP) of Services?
Offer a terse response. 5.49. In the year 1996, what is the difference between the Value added (% of GDP) in Industry and Value added (% of GDP) in Agriculture?
Your answer should be very brief. 21.89. In the year 1996, what is the difference between the Value added (% of GDP) in Manufacturing and Value added (% of GDP) in Services?
Make the answer very short. -15.36. In the year 1996, what is the difference between the Value added (% of GDP) of Manufacturing and Value added (% of GDP) of Agriculture?
Keep it short and to the point. 1.04. In the year 1996, what is the difference between the Value added (% of GDP) in Services and Value added (% of GDP) in Agriculture?
Give a very brief answer. 16.4. In the year 1997, what is the difference between the Value added (% of GDP) of Industry and Value added (% of GDP) of Manufacturing?
Your response must be concise. 17.15. In the year 1997, what is the difference between the Value added (% of GDP) in Industry and Value added (% of GDP) in Services?
Offer a terse response. -1.99. In the year 1997, what is the difference between the Value added (% of GDP) of Industry and Value added (% of GDP) of Agriculture?
Your answer should be compact. 19.67. In the year 1997, what is the difference between the Value added (% of GDP) in Manufacturing and Value added (% of GDP) in Services?
Give a very brief answer. -19.14. In the year 1997, what is the difference between the Value added (% of GDP) of Manufacturing and Value added (% of GDP) of Agriculture?
Your answer should be compact. 2.52. In the year 1997, what is the difference between the Value added (% of GDP) in Services and Value added (% of GDP) in Agriculture?
Provide a succinct answer. 21.66. In the year 1998, what is the difference between the Value added (% of GDP) in Industry and Value added (% of GDP) in Manufacturing?
Your answer should be compact. 5.35. In the year 1998, what is the difference between the Value added (% of GDP) in Industry and Value added (% of GDP) in Services?
Keep it short and to the point. -24.81. In the year 1998, what is the difference between the Value added (% of GDP) in Industry and Value added (% of GDP) in Agriculture?
Make the answer very short. 13.68. In the year 1998, what is the difference between the Value added (% of GDP) in Manufacturing and Value added (% of GDP) in Services?
Your answer should be very brief. -30.16. In the year 1998, what is the difference between the Value added (% of GDP) in Manufacturing and Value added (% of GDP) in Agriculture?
Your answer should be compact. 8.33. In the year 1998, what is the difference between the Value added (% of GDP) of Services and Value added (% of GDP) of Agriculture?
Provide a succinct answer. 38.49. In the year 1999, what is the difference between the Value added (% of GDP) in Industry and Value added (% of GDP) in Manufacturing?
Give a very brief answer. 3.94. In the year 1999, what is the difference between the Value added (% of GDP) in Industry and Value added (% of GDP) in Services?
Provide a succinct answer. -29.73. In the year 1999, what is the difference between the Value added (% of GDP) in Industry and Value added (% of GDP) in Agriculture?
Offer a terse response. 13.98. In the year 1999, what is the difference between the Value added (% of GDP) of Manufacturing and Value added (% of GDP) of Services?
Your answer should be very brief. -33.67. In the year 1999, what is the difference between the Value added (% of GDP) in Manufacturing and Value added (% of GDP) in Agriculture?
Keep it short and to the point. 10.04. In the year 1999, what is the difference between the Value added (% of GDP) in Services and Value added (% of GDP) in Agriculture?
Your answer should be very brief. 43.71. In the year 2000, what is the difference between the Value added (% of GDP) of Industry and Value added (% of GDP) of Manufacturing?
Give a very brief answer. 4.91. In the year 2000, what is the difference between the Value added (% of GDP) in Industry and Value added (% of GDP) in Services?
Your answer should be compact. -32.51. In the year 2000, what is the difference between the Value added (% of GDP) of Industry and Value added (% of GDP) of Agriculture?
Your answer should be very brief. 15.71. In the year 2000, what is the difference between the Value added (% of GDP) of Manufacturing and Value added (% of GDP) of Services?
Your answer should be compact. -37.42. In the year 2000, what is the difference between the Value added (% of GDP) of Manufacturing and Value added (% of GDP) of Agriculture?
Keep it short and to the point. 10.81. In the year 2000, what is the difference between the Value added (% of GDP) in Services and Value added (% of GDP) in Agriculture?
Keep it short and to the point. 48.23. In the year 2001, what is the difference between the Value added (% of GDP) in Industry and Value added (% of GDP) in Manufacturing?
Provide a short and direct response. 5.98. In the year 2001, what is the difference between the Value added (% of GDP) in Industry and Value added (% of GDP) in Services?
Your answer should be very brief. -26.78. In the year 2001, what is the difference between the Value added (% of GDP) of Industry and Value added (% of GDP) of Agriculture?
Your response must be concise. 14.87. In the year 2001, what is the difference between the Value added (% of GDP) in Manufacturing and Value added (% of GDP) in Services?
Offer a very short reply. -32.76. In the year 2001, what is the difference between the Value added (% of GDP) in Manufacturing and Value added (% of GDP) in Agriculture?
Offer a very short reply. 8.89. In the year 2001, what is the difference between the Value added (% of GDP) in Services and Value added (% of GDP) in Agriculture?
Keep it short and to the point. 41.65. In the year 2002, what is the difference between the Value added (% of GDP) of Industry and Value added (% of GDP) of Manufacturing?
Offer a terse response. 6.3. In the year 2002, what is the difference between the Value added (% of GDP) of Industry and Value added (% of GDP) of Services?
Your answer should be very brief. -27.31. In the year 2002, what is the difference between the Value added (% of GDP) of Industry and Value added (% of GDP) of Agriculture?
Your answer should be very brief. 17.51. In the year 2002, what is the difference between the Value added (% of GDP) of Manufacturing and Value added (% of GDP) of Services?
Your answer should be compact. -33.62. In the year 2002, what is the difference between the Value added (% of GDP) in Manufacturing and Value added (% of GDP) in Agriculture?
Your answer should be compact. 11.2. In the year 2002, what is the difference between the Value added (% of GDP) in Services and Value added (% of GDP) in Agriculture?
Provide a succinct answer. 44.82. In the year 2003, what is the difference between the Value added (% of GDP) of Industry and Value added (% of GDP) of Manufacturing?
Your answer should be compact. 4.32. In the year 2003, what is the difference between the Value added (% of GDP) in Industry and Value added (% of GDP) in Services?
Give a very brief answer. -31.26. In the year 2003, what is the difference between the Value added (% of GDP) in Industry and Value added (% of GDP) in Agriculture?
Provide a short and direct response. 14.99. In the year 2003, what is the difference between the Value added (% of GDP) in Manufacturing and Value added (% of GDP) in Services?
Offer a very short reply. -35.58. In the year 2003, what is the difference between the Value added (% of GDP) in Manufacturing and Value added (% of GDP) in Agriculture?
Your answer should be compact. 10.67. In the year 2003, what is the difference between the Value added (% of GDP) in Services and Value added (% of GDP) in Agriculture?
Provide a succinct answer. 46.25. What is the ratio of the Value added (% of GDP) of Industry in 1996 to that in 1997?
Your answer should be very brief. 1.08. What is the ratio of the Value added (% of GDP) of Manufacturing in 1996 to that in 1997?
Your answer should be very brief. 0.98. What is the ratio of the Value added (% of GDP) of Services in 1996 to that in 1997?
Keep it short and to the point. 0.9. What is the ratio of the Value added (% of GDP) of Agriculture in 1996 to that in 1997?
Make the answer very short. 1.05. What is the ratio of the Value added (% of GDP) in Industry in 1996 to that in 1998?
Your response must be concise. 1.43. What is the ratio of the Value added (% of GDP) in Manufacturing in 1996 to that in 1998?
Keep it short and to the point. 0.89. What is the ratio of the Value added (% of GDP) in Services in 1996 to that in 1998?
Offer a very short reply. 0.68. What is the ratio of the Value added (% of GDP) in Agriculture in 1996 to that in 1998?
Make the answer very short. 1.29. What is the ratio of the Value added (% of GDP) of Industry in 1996 to that in 1999?
Keep it short and to the point. 1.51. What is the ratio of the Value added (% of GDP) of Manufacturing in 1996 to that in 1999?
Your response must be concise. 0.9. What is the ratio of the Value added (% of GDP) in Services in 1996 to that in 1999?
Ensure brevity in your answer.  0.64. What is the ratio of the Value added (% of GDP) in Agriculture in 1996 to that in 1999?
Give a very brief answer. 1.46. What is the ratio of the Value added (% of GDP) of Industry in 1996 to that in 2000?
Offer a terse response. 1.53. What is the ratio of the Value added (% of GDP) in Manufacturing in 1996 to that in 2000?
Keep it short and to the point. 0.95. What is the ratio of the Value added (% of GDP) in Services in 1996 to that in 2000?
Make the answer very short. 0.61. What is the ratio of the Value added (% of GDP) in Agriculture in 1996 to that in 2000?
Keep it short and to the point. 1.71. What is the ratio of the Value added (% of GDP) in Industry in 1996 to that in 2001?
Your answer should be very brief. 1.45. What is the ratio of the Value added (% of GDP) in Manufacturing in 1996 to that in 2001?
Your response must be concise. 0.92. What is the ratio of the Value added (% of GDP) in Services in 1996 to that in 2001?
Provide a succinct answer. 0.66. What is the ratio of the Value added (% of GDP) of Agriculture in 1996 to that in 2001?
Give a very brief answer. 1.42. What is the ratio of the Value added (% of GDP) in Industry in 1996 to that in 2002?
Provide a succinct answer. 1.41. What is the ratio of the Value added (% of GDP) of Manufacturing in 1996 to that in 2002?
Ensure brevity in your answer.  0.91. What is the ratio of the Value added (% of GDP) of Services in 1996 to that in 2002?
Your answer should be very brief. 0.64. What is the ratio of the Value added (% of GDP) in Agriculture in 1996 to that in 2002?
Your response must be concise. 1.64. What is the ratio of the Value added (% of GDP) of Industry in 1996 to that in 2003?
Keep it short and to the point. 1.52. What is the ratio of the Value added (% of GDP) of Manufacturing in 1996 to that in 2003?
Provide a short and direct response. 0.92. What is the ratio of the Value added (% of GDP) of Services in 1996 to that in 2003?
Provide a short and direct response. 0.62. What is the ratio of the Value added (% of GDP) of Agriculture in 1996 to that in 2003?
Provide a short and direct response. 1.59. What is the ratio of the Value added (% of GDP) in Industry in 1997 to that in 1998?
Offer a terse response. 1.32. What is the ratio of the Value added (% of GDP) of Manufacturing in 1997 to that in 1998?
Your answer should be compact. 0.91. What is the ratio of the Value added (% of GDP) in Services in 1997 to that in 1998?
Keep it short and to the point. 0.76. What is the ratio of the Value added (% of GDP) of Agriculture in 1997 to that in 1998?
Your answer should be very brief. 1.23. What is the ratio of the Value added (% of GDP) in Industry in 1997 to that in 1999?
Keep it short and to the point. 1.4. What is the ratio of the Value added (% of GDP) in Manufacturing in 1997 to that in 1999?
Your answer should be very brief. 0.91. What is the ratio of the Value added (% of GDP) of Services in 1997 to that in 1999?
Offer a terse response. 0.71. What is the ratio of the Value added (% of GDP) in Agriculture in 1997 to that in 1999?
Your response must be concise. 1.39. What is the ratio of the Value added (% of GDP) in Industry in 1997 to that in 2000?
Offer a very short reply. 1.41. What is the ratio of the Value added (% of GDP) in Manufacturing in 1997 to that in 2000?
Your response must be concise. 0.97. What is the ratio of the Value added (% of GDP) of Services in 1997 to that in 2000?
Ensure brevity in your answer.  0.68. What is the ratio of the Value added (% of GDP) in Agriculture in 1997 to that in 2000?
Keep it short and to the point. 1.63. What is the ratio of the Value added (% of GDP) of Industry in 1997 to that in 2001?
Offer a terse response. 1.34. What is the ratio of the Value added (% of GDP) of Manufacturing in 1997 to that in 2001?
Provide a short and direct response. 0.94. What is the ratio of the Value added (% of GDP) of Services in 1997 to that in 2001?
Offer a very short reply. 0.73. What is the ratio of the Value added (% of GDP) in Agriculture in 1997 to that in 2001?
Your answer should be very brief. 1.35. What is the ratio of the Value added (% of GDP) of Industry in 1997 to that in 2002?
Keep it short and to the point. 1.3. What is the ratio of the Value added (% of GDP) in Manufacturing in 1997 to that in 2002?
Ensure brevity in your answer.  0.93. What is the ratio of the Value added (% of GDP) in Services in 1997 to that in 2002?
Make the answer very short. 0.72. What is the ratio of the Value added (% of GDP) of Agriculture in 1997 to that in 2002?
Keep it short and to the point. 1.56. What is the ratio of the Value added (% of GDP) of Industry in 1997 to that in 2003?
Your answer should be very brief. 1.41. What is the ratio of the Value added (% of GDP) of Manufacturing in 1997 to that in 2003?
Your response must be concise. 0.94. What is the ratio of the Value added (% of GDP) of Services in 1997 to that in 2003?
Offer a terse response. 0.7. What is the ratio of the Value added (% of GDP) of Agriculture in 1997 to that in 2003?
Your answer should be very brief. 1.51. What is the ratio of the Value added (% of GDP) of Industry in 1998 to that in 1999?
Make the answer very short. 1.05. What is the ratio of the Value added (% of GDP) in Manufacturing in 1998 to that in 1999?
Your response must be concise. 1.01. What is the ratio of the Value added (% of GDP) of Services in 1998 to that in 1999?
Your response must be concise. 0.94. What is the ratio of the Value added (% of GDP) in Agriculture in 1998 to that in 1999?
Make the answer very short. 1.13. What is the ratio of the Value added (% of GDP) in Industry in 1998 to that in 2000?
Provide a short and direct response. 1.07. What is the ratio of the Value added (% of GDP) of Manufacturing in 1998 to that in 2000?
Your answer should be very brief. 1.06. What is the ratio of the Value added (% of GDP) of Services in 1998 to that in 2000?
Keep it short and to the point. 0.9. What is the ratio of the Value added (% of GDP) of Agriculture in 1998 to that in 2000?
Your response must be concise. 1.33. What is the ratio of the Value added (% of GDP) in Industry in 1998 to that in 2001?
Your response must be concise. 1.01. What is the ratio of the Value added (% of GDP) of Manufacturing in 1998 to that in 2001?
Offer a terse response. 1.04. What is the ratio of the Value added (% of GDP) in Services in 1998 to that in 2001?
Your answer should be compact. 0.97. What is the ratio of the Value added (% of GDP) in Agriculture in 1998 to that in 2001?
Your answer should be compact. 1.1. What is the ratio of the Value added (% of GDP) in Manufacturing in 1998 to that in 2002?
Provide a short and direct response. 1.02. What is the ratio of the Value added (% of GDP) of Services in 1998 to that in 2002?
Provide a short and direct response. 0.95. What is the ratio of the Value added (% of GDP) of Agriculture in 1998 to that in 2002?
Offer a very short reply. 1.27. What is the ratio of the Value added (% of GDP) of Industry in 1998 to that in 2003?
Offer a very short reply. 1.06. What is the ratio of the Value added (% of GDP) in Services in 1998 to that in 2003?
Your answer should be very brief. 0.92. What is the ratio of the Value added (% of GDP) of Agriculture in 1998 to that in 2003?
Offer a terse response. 1.23. What is the ratio of the Value added (% of GDP) in Industry in 1999 to that in 2000?
Your answer should be compact. 1.01. What is the ratio of the Value added (% of GDP) of Manufacturing in 1999 to that in 2000?
Offer a very short reply. 1.06. What is the ratio of the Value added (% of GDP) of Services in 1999 to that in 2000?
Provide a succinct answer. 0.96. What is the ratio of the Value added (% of GDP) in Agriculture in 1999 to that in 2000?
Keep it short and to the point. 1.17. What is the ratio of the Value added (% of GDP) of Industry in 1999 to that in 2001?
Your response must be concise. 0.96. What is the ratio of the Value added (% of GDP) in Manufacturing in 1999 to that in 2001?
Your answer should be very brief. 1.03. What is the ratio of the Value added (% of GDP) of Services in 1999 to that in 2001?
Provide a short and direct response. 1.03. What is the ratio of the Value added (% of GDP) of Agriculture in 1999 to that in 2001?
Provide a short and direct response. 0.97. What is the ratio of the Value added (% of GDP) of Industry in 1999 to that in 2002?
Give a very brief answer. 0.93. What is the ratio of the Value added (% of GDP) in Manufacturing in 1999 to that in 2002?
Provide a succinct answer. 1.02. What is the ratio of the Value added (% of GDP) of Services in 1999 to that in 2002?
Keep it short and to the point. 1.01. What is the ratio of the Value added (% of GDP) of Agriculture in 1999 to that in 2002?
Ensure brevity in your answer.  1.12. What is the ratio of the Value added (% of GDP) of Industry in 1999 to that in 2003?
Your response must be concise. 1.01. What is the ratio of the Value added (% of GDP) in Manufacturing in 1999 to that in 2003?
Provide a short and direct response. 1.02. What is the ratio of the Value added (% of GDP) of Services in 1999 to that in 2003?
Ensure brevity in your answer.  0.98. What is the ratio of the Value added (% of GDP) of Agriculture in 1999 to that in 2003?
Ensure brevity in your answer.  1.09. What is the ratio of the Value added (% of GDP) in Industry in 2000 to that in 2001?
Make the answer very short. 0.94. What is the ratio of the Value added (% of GDP) of Manufacturing in 2000 to that in 2001?
Provide a succinct answer. 0.98. What is the ratio of the Value added (% of GDP) in Services in 2000 to that in 2001?
Offer a terse response. 1.07. What is the ratio of the Value added (% of GDP) of Agriculture in 2000 to that in 2001?
Provide a short and direct response. 0.83. What is the ratio of the Value added (% of GDP) in Industry in 2000 to that in 2002?
Offer a very short reply. 0.92. What is the ratio of the Value added (% of GDP) in Manufacturing in 2000 to that in 2002?
Your answer should be very brief. 0.96. What is the ratio of the Value added (% of GDP) in Agriculture in 2000 to that in 2002?
Make the answer very short. 0.96. What is the ratio of the Value added (% of GDP) in Manufacturing in 2000 to that in 2003?
Ensure brevity in your answer.  0.97. What is the ratio of the Value added (% of GDP) of Services in 2000 to that in 2003?
Ensure brevity in your answer.  1.02. What is the ratio of the Value added (% of GDP) of Agriculture in 2000 to that in 2003?
Your response must be concise. 0.93. What is the ratio of the Value added (% of GDP) in Industry in 2001 to that in 2002?
Make the answer very short. 0.98. What is the ratio of the Value added (% of GDP) of Services in 2001 to that in 2002?
Your response must be concise. 0.98. What is the ratio of the Value added (% of GDP) of Agriculture in 2001 to that in 2002?
Give a very brief answer. 1.15. What is the ratio of the Value added (% of GDP) in Industry in 2001 to that in 2003?
Provide a succinct answer. 1.05. What is the ratio of the Value added (% of GDP) in Services in 2001 to that in 2003?
Your response must be concise. 0.95. What is the ratio of the Value added (% of GDP) in Agriculture in 2001 to that in 2003?
Your answer should be very brief. 1.12. What is the ratio of the Value added (% of GDP) in Industry in 2002 to that in 2003?
Make the answer very short. 1.08. What is the ratio of the Value added (% of GDP) in Manufacturing in 2002 to that in 2003?
Offer a terse response. 1.01. What is the ratio of the Value added (% of GDP) in Services in 2002 to that in 2003?
Ensure brevity in your answer.  0.97. What is the ratio of the Value added (% of GDP) of Agriculture in 2002 to that in 2003?
Provide a succinct answer. 0.97. What is the difference between the highest and the second highest Value added (% of GDP) in Industry?
Give a very brief answer. 3.24. What is the difference between the highest and the second highest Value added (% of GDP) of Manufacturing?
Keep it short and to the point. 0.13. What is the difference between the highest and the second highest Value added (% of GDP) in Services?
Your answer should be very brief. 1.08. What is the difference between the highest and the second highest Value added (% of GDP) of Agriculture?
Your answer should be compact. 1.01. What is the difference between the highest and the lowest Value added (% of GDP) in Industry?
Your answer should be compact. 14.73. What is the difference between the highest and the lowest Value added (% of GDP) in Manufacturing?
Your response must be concise. 2.66. What is the difference between the highest and the lowest Value added (% of GDP) in Services?
Offer a terse response. 23.28. What is the difference between the highest and the lowest Value added (% of GDP) in Agriculture?
Ensure brevity in your answer.  8.55. 